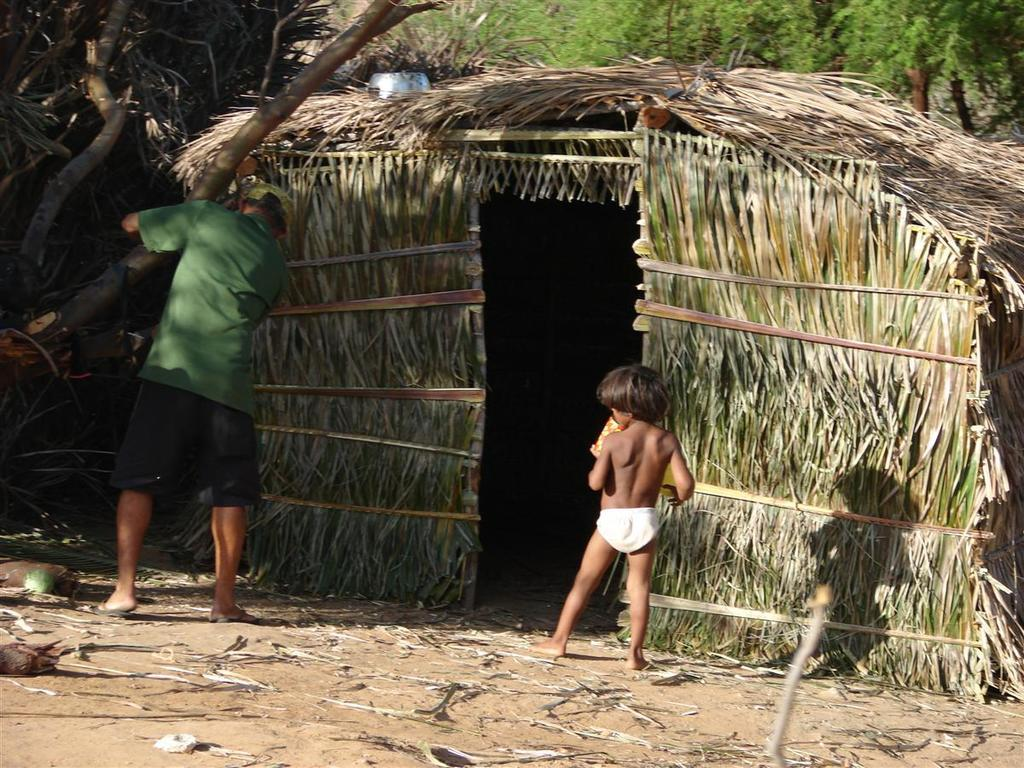Who can be seen standing in the image? There is a man and a kid standing in the image. What type of structure is visible in the background? The image appears to depict a hut. What type of vegetation is present in the image? There are trees in the image. What is lying on the ground in the image? Dried leaves are lying on the ground in the image. What month is it in the image? The month cannot be determined from the image, as there is no information about the time of year or any specific calendar date. 